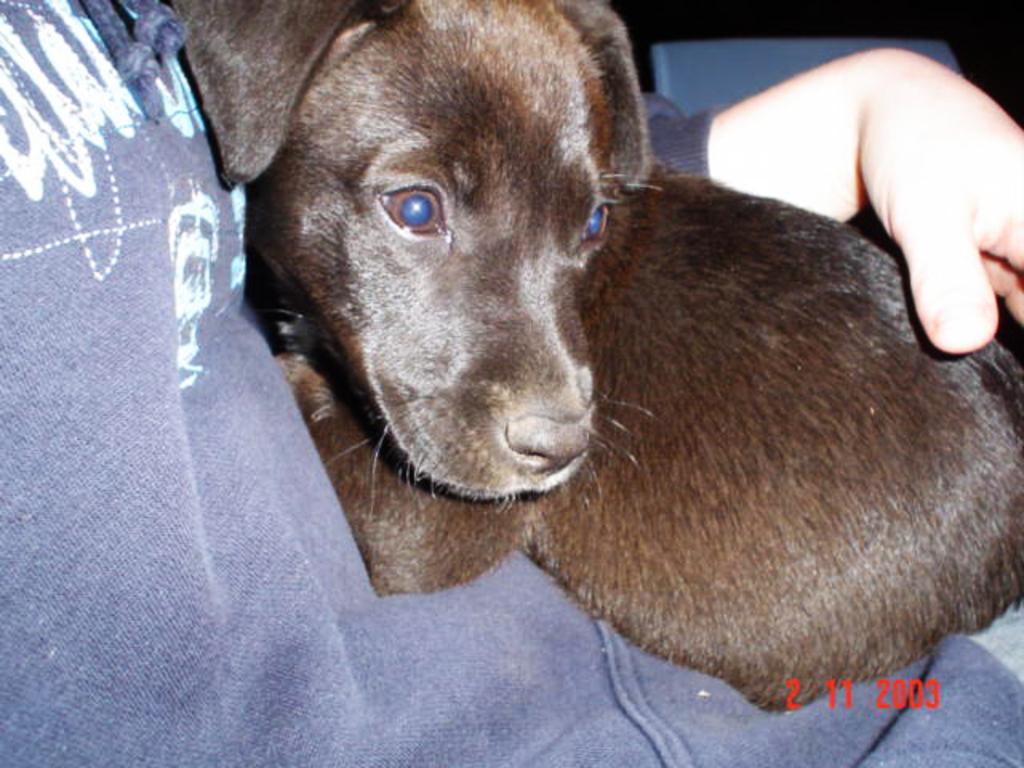Please provide a concise description of this image. This image consists of a person. He is holding a dog. It is in brown color. 